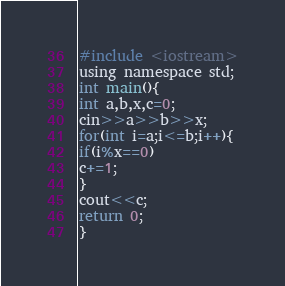<code> <loc_0><loc_0><loc_500><loc_500><_C_>#include <iostream>
using namespace std;
int main(){
int a,b,x,c=0;
cin>>a>>b>>x;
for(int i=a;i<=b;i++){
if(i%x==0)
c+=1;
}
cout<<c;
return 0;
}</code> 